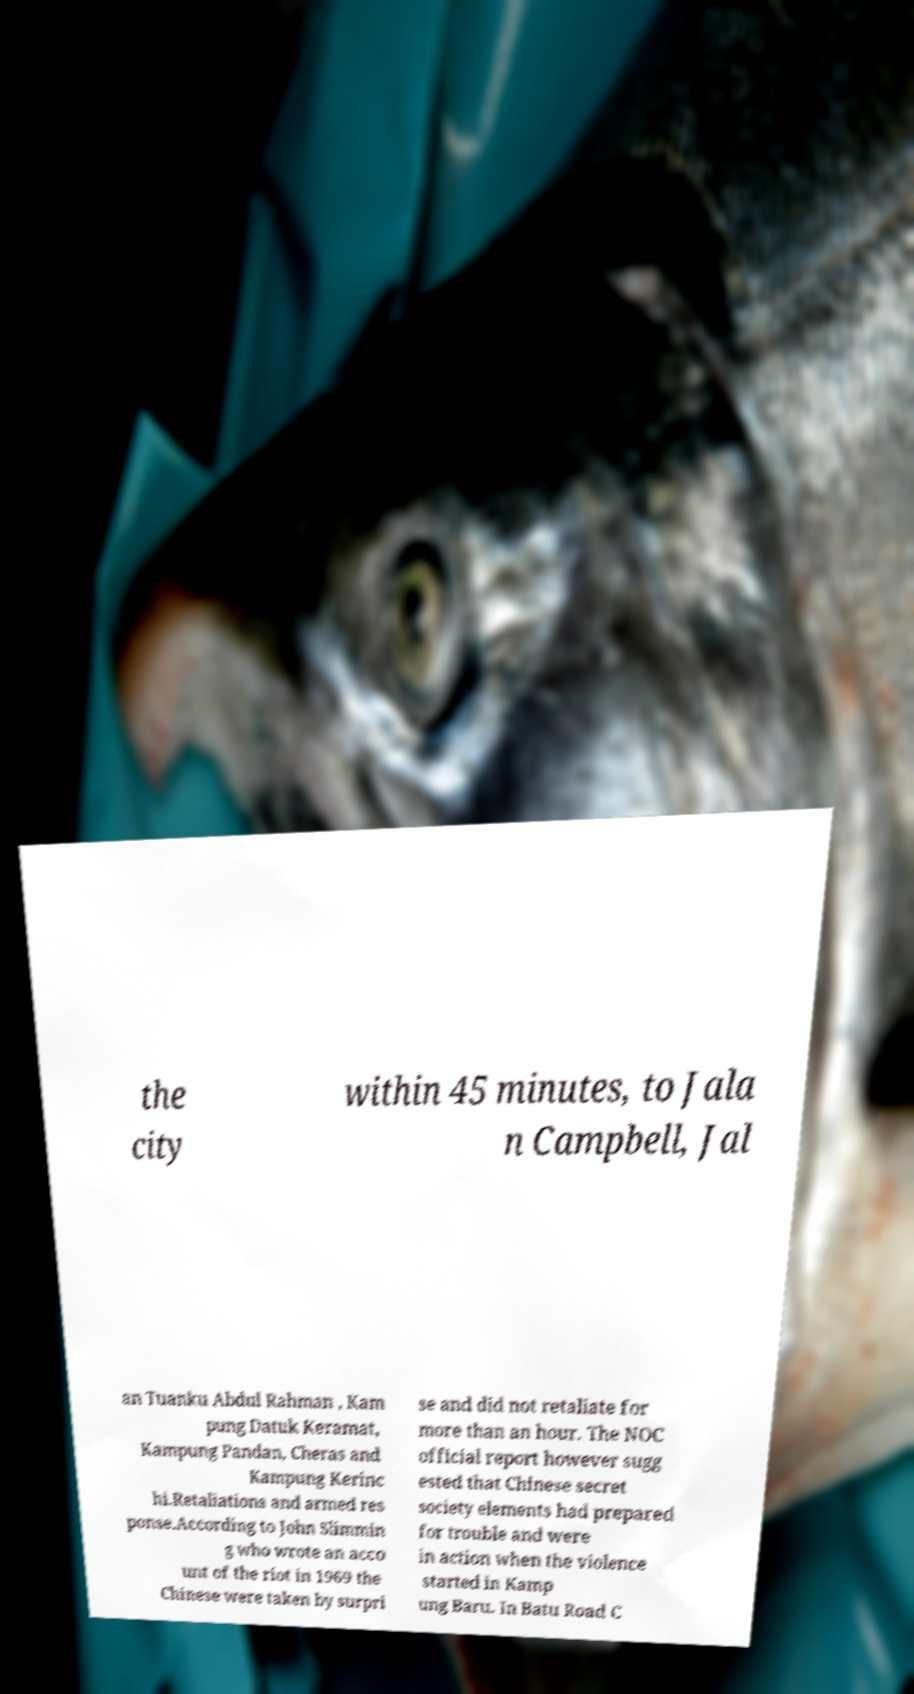For documentation purposes, I need the text within this image transcribed. Could you provide that? the city within 45 minutes, to Jala n Campbell, Jal an Tuanku Abdul Rahman , Kam pung Datuk Keramat, Kampung Pandan, Cheras and Kampung Kerinc hi.Retaliations and armed res ponse.According to John Slimmin g who wrote an acco unt of the riot in 1969 the Chinese were taken by surpri se and did not retaliate for more than an hour. The NOC official report however sugg ested that Chinese secret society elements had prepared for trouble and were in action when the violence started in Kamp ung Baru. In Batu Road C 